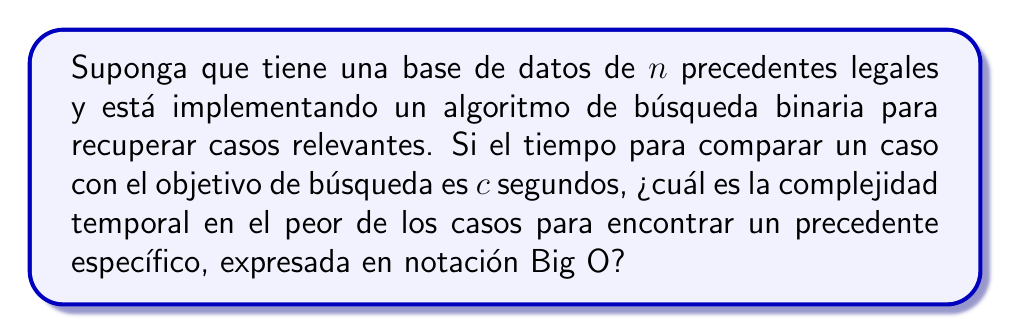Can you answer this question? Para resolver este problema, seguiremos estos pasos:

1) La búsqueda binaria divide repetidamente el espacio de búsqueda a la mitad en cada iteración.

2) El número máximo de divisiones que se pueden hacer en una lista de $n$ elementos antes de llegar a un solo elemento es $\log_2(n)$.

3) En cada división, se realiza una comparación que toma $c$ segundos.

4) Por lo tanto, el tiempo total en el peor caso será:

   $$T(n) = c \cdot \log_2(n)$$

5) En notación Big O, las constantes se omiten, por lo que $c$ se elimina.

6) Además, en Big O, el logaritmo en cualquier base es equivalente (difieren solo por una constante), por lo que podemos escribir simplemente $\log n$.

Por lo tanto, la complejidad temporal en el peor caso es $O(\log n)$.

Esta eficiencia logarítmica hace que la búsqueda binaria sea mucho más rápida que una búsqueda lineal (que sería $O(n)$) para bases de datos grandes, lo que la hace ideal para sistemas de recuperación de precedentes legales con muchos casos almacenados.
Answer: $O(\log n)$ 